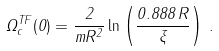<formula> <loc_0><loc_0><loc_500><loc_500>\Omega _ { c } ^ { T F } ( 0 ) = \frac { 2 } { m R ^ { 2 } } \ln \left ( \frac { 0 . 8 8 8 \, R } { \xi } \right ) \, .</formula> 